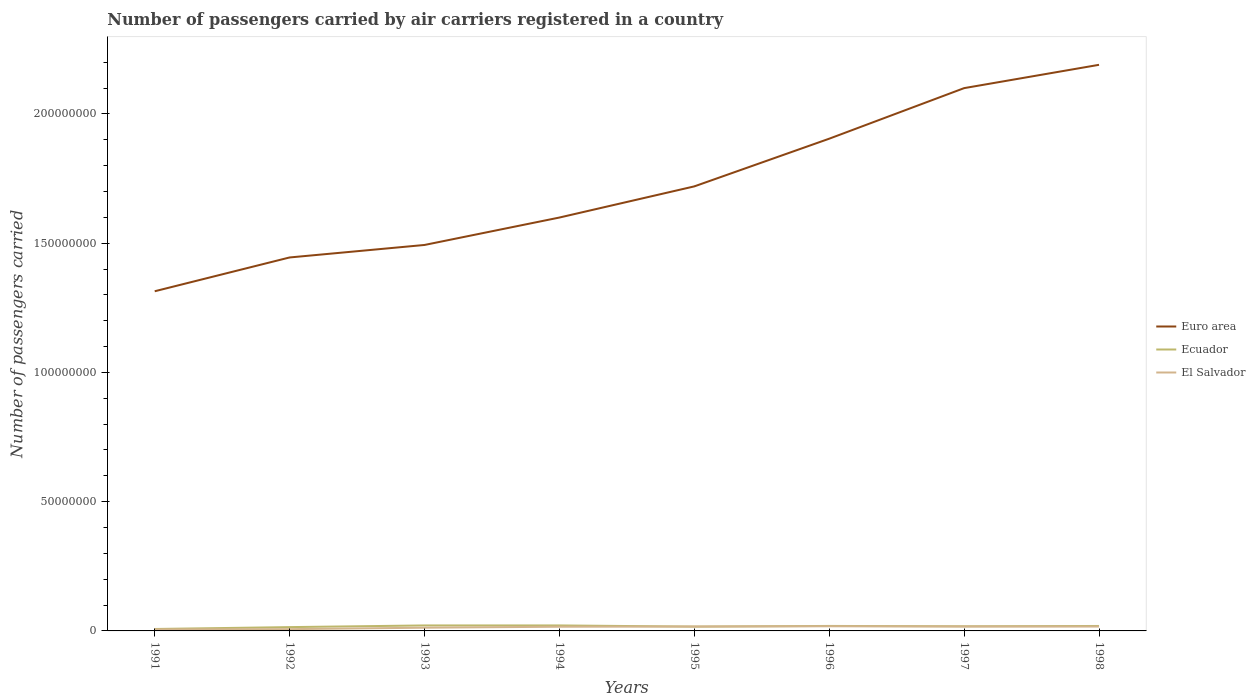Is the number of lines equal to the number of legend labels?
Give a very brief answer. Yes. Across all years, what is the maximum number of passengers carried by air carriers in Ecuador?
Ensure brevity in your answer.  7.52e+05. What is the total number of passengers carried by air carriers in Euro area in the graph?
Provide a short and direct response. -7.45e+07. What is the difference between the highest and the second highest number of passengers carried by air carriers in Ecuador?
Your answer should be very brief. 1.37e+06. How many lines are there?
Offer a terse response. 3. How many years are there in the graph?
Provide a short and direct response. 8. What is the difference between two consecutive major ticks on the Y-axis?
Your answer should be very brief. 5.00e+07. Where does the legend appear in the graph?
Make the answer very short. Center right. What is the title of the graph?
Your response must be concise. Number of passengers carried by air carriers registered in a country. What is the label or title of the Y-axis?
Your answer should be compact. Number of passengers carried. What is the Number of passengers carried of Euro area in 1991?
Provide a succinct answer. 1.31e+08. What is the Number of passengers carried of Ecuador in 1991?
Provide a succinct answer. 7.52e+05. What is the Number of passengers carried of El Salvador in 1991?
Make the answer very short. 5.77e+05. What is the Number of passengers carried of Euro area in 1992?
Your response must be concise. 1.44e+08. What is the Number of passengers carried of Ecuador in 1992?
Keep it short and to the point. 1.47e+06. What is the Number of passengers carried of El Salvador in 1992?
Provide a succinct answer. 6.83e+05. What is the Number of passengers carried of Euro area in 1993?
Keep it short and to the point. 1.49e+08. What is the Number of passengers carried in Ecuador in 1993?
Keep it short and to the point. 2.12e+06. What is the Number of passengers carried in El Salvador in 1993?
Provide a short and direct response. 1.24e+06. What is the Number of passengers carried of Euro area in 1994?
Your response must be concise. 1.60e+08. What is the Number of passengers carried in Ecuador in 1994?
Your answer should be very brief. 2.12e+06. What is the Number of passengers carried in El Salvador in 1994?
Offer a very short reply. 1.62e+06. What is the Number of passengers carried in Euro area in 1995?
Give a very brief answer. 1.72e+08. What is the Number of passengers carried in Ecuador in 1995?
Your answer should be compact. 1.67e+06. What is the Number of passengers carried in El Salvador in 1995?
Offer a terse response. 1.70e+06. What is the Number of passengers carried in Euro area in 1996?
Your answer should be very brief. 1.90e+08. What is the Number of passengers carried of Ecuador in 1996?
Your answer should be compact. 1.93e+06. What is the Number of passengers carried in El Salvador in 1996?
Provide a succinct answer. 1.80e+06. What is the Number of passengers carried in Euro area in 1997?
Make the answer very short. 2.10e+08. What is the Number of passengers carried in Ecuador in 1997?
Offer a terse response. 1.79e+06. What is the Number of passengers carried of El Salvador in 1997?
Your response must be concise. 1.70e+06. What is the Number of passengers carried of Euro area in 1998?
Offer a very short reply. 2.19e+08. What is the Number of passengers carried in Ecuador in 1998?
Offer a very short reply. 1.92e+06. What is the Number of passengers carried in El Salvador in 1998?
Keep it short and to the point. 1.69e+06. Across all years, what is the maximum Number of passengers carried of Euro area?
Give a very brief answer. 2.19e+08. Across all years, what is the maximum Number of passengers carried of Ecuador?
Offer a very short reply. 2.12e+06. Across all years, what is the maximum Number of passengers carried in El Salvador?
Offer a terse response. 1.80e+06. Across all years, what is the minimum Number of passengers carried in Euro area?
Provide a short and direct response. 1.31e+08. Across all years, what is the minimum Number of passengers carried in Ecuador?
Your response must be concise. 7.52e+05. Across all years, what is the minimum Number of passengers carried of El Salvador?
Offer a very short reply. 5.77e+05. What is the total Number of passengers carried in Euro area in the graph?
Offer a terse response. 1.38e+09. What is the total Number of passengers carried in Ecuador in the graph?
Your response must be concise. 1.38e+07. What is the total Number of passengers carried of El Salvador in the graph?
Provide a succinct answer. 1.10e+07. What is the difference between the Number of passengers carried of Euro area in 1991 and that in 1992?
Make the answer very short. -1.31e+07. What is the difference between the Number of passengers carried in Ecuador in 1991 and that in 1992?
Provide a succinct answer. -7.22e+05. What is the difference between the Number of passengers carried of El Salvador in 1991 and that in 1992?
Keep it short and to the point. -1.06e+05. What is the difference between the Number of passengers carried of Euro area in 1991 and that in 1993?
Give a very brief answer. -1.79e+07. What is the difference between the Number of passengers carried in Ecuador in 1991 and that in 1993?
Provide a succinct answer. -1.37e+06. What is the difference between the Number of passengers carried of El Salvador in 1991 and that in 1993?
Your answer should be very brief. -6.65e+05. What is the difference between the Number of passengers carried of Euro area in 1991 and that in 1994?
Ensure brevity in your answer.  -2.85e+07. What is the difference between the Number of passengers carried of Ecuador in 1991 and that in 1994?
Ensure brevity in your answer.  -1.37e+06. What is the difference between the Number of passengers carried of El Salvador in 1991 and that in 1994?
Keep it short and to the point. -1.04e+06. What is the difference between the Number of passengers carried of Euro area in 1991 and that in 1995?
Give a very brief answer. -4.06e+07. What is the difference between the Number of passengers carried in Ecuador in 1991 and that in 1995?
Ensure brevity in your answer.  -9.19e+05. What is the difference between the Number of passengers carried in El Salvador in 1991 and that in 1995?
Give a very brief answer. -1.12e+06. What is the difference between the Number of passengers carried in Euro area in 1991 and that in 1996?
Offer a terse response. -5.90e+07. What is the difference between the Number of passengers carried of Ecuador in 1991 and that in 1996?
Give a very brief answer. -1.17e+06. What is the difference between the Number of passengers carried of El Salvador in 1991 and that in 1996?
Your answer should be very brief. -1.22e+06. What is the difference between the Number of passengers carried in Euro area in 1991 and that in 1997?
Your answer should be very brief. -7.86e+07. What is the difference between the Number of passengers carried of Ecuador in 1991 and that in 1997?
Your answer should be very brief. -1.04e+06. What is the difference between the Number of passengers carried of El Salvador in 1991 and that in 1997?
Give a very brief answer. -1.12e+06. What is the difference between the Number of passengers carried of Euro area in 1991 and that in 1998?
Keep it short and to the point. -8.76e+07. What is the difference between the Number of passengers carried in Ecuador in 1991 and that in 1998?
Provide a short and direct response. -1.17e+06. What is the difference between the Number of passengers carried of El Salvador in 1991 and that in 1998?
Offer a very short reply. -1.12e+06. What is the difference between the Number of passengers carried of Euro area in 1992 and that in 1993?
Make the answer very short. -4.83e+06. What is the difference between the Number of passengers carried of Ecuador in 1992 and that in 1993?
Ensure brevity in your answer.  -6.48e+05. What is the difference between the Number of passengers carried in El Salvador in 1992 and that in 1993?
Offer a very short reply. -5.60e+05. What is the difference between the Number of passengers carried of Euro area in 1992 and that in 1994?
Your answer should be very brief. -1.54e+07. What is the difference between the Number of passengers carried of Ecuador in 1992 and that in 1994?
Offer a terse response. -6.45e+05. What is the difference between the Number of passengers carried in El Salvador in 1992 and that in 1994?
Make the answer very short. -9.34e+05. What is the difference between the Number of passengers carried in Euro area in 1992 and that in 1995?
Offer a very short reply. -2.75e+07. What is the difference between the Number of passengers carried in Ecuador in 1992 and that in 1995?
Ensure brevity in your answer.  -1.97e+05. What is the difference between the Number of passengers carried of El Salvador in 1992 and that in 1995?
Make the answer very short. -1.02e+06. What is the difference between the Number of passengers carried in Euro area in 1992 and that in 1996?
Offer a terse response. -4.59e+07. What is the difference between the Number of passengers carried in Ecuador in 1992 and that in 1996?
Provide a succinct answer. -4.51e+05. What is the difference between the Number of passengers carried of El Salvador in 1992 and that in 1996?
Offer a terse response. -1.12e+06. What is the difference between the Number of passengers carried in Euro area in 1992 and that in 1997?
Provide a short and direct response. -6.55e+07. What is the difference between the Number of passengers carried in Ecuador in 1992 and that in 1997?
Offer a terse response. -3.17e+05. What is the difference between the Number of passengers carried of El Salvador in 1992 and that in 1997?
Ensure brevity in your answer.  -1.02e+06. What is the difference between the Number of passengers carried in Euro area in 1992 and that in 1998?
Give a very brief answer. -7.45e+07. What is the difference between the Number of passengers carried of Ecuador in 1992 and that in 1998?
Provide a short and direct response. -4.45e+05. What is the difference between the Number of passengers carried in El Salvador in 1992 and that in 1998?
Your answer should be very brief. -1.01e+06. What is the difference between the Number of passengers carried of Euro area in 1993 and that in 1994?
Your answer should be very brief. -1.06e+07. What is the difference between the Number of passengers carried in Ecuador in 1993 and that in 1994?
Make the answer very short. 3700. What is the difference between the Number of passengers carried in El Salvador in 1993 and that in 1994?
Ensure brevity in your answer.  -3.75e+05. What is the difference between the Number of passengers carried of Euro area in 1993 and that in 1995?
Provide a short and direct response. -2.27e+07. What is the difference between the Number of passengers carried in Ecuador in 1993 and that in 1995?
Provide a short and direct response. 4.52e+05. What is the difference between the Number of passengers carried of El Salvador in 1993 and that in 1995?
Offer a terse response. -4.56e+05. What is the difference between the Number of passengers carried in Euro area in 1993 and that in 1996?
Keep it short and to the point. -4.11e+07. What is the difference between the Number of passengers carried of Ecuador in 1993 and that in 1996?
Your answer should be compact. 1.97e+05. What is the difference between the Number of passengers carried in El Salvador in 1993 and that in 1996?
Your answer should be compact. -5.58e+05. What is the difference between the Number of passengers carried of Euro area in 1993 and that in 1997?
Offer a terse response. -6.07e+07. What is the difference between the Number of passengers carried of Ecuador in 1993 and that in 1997?
Your answer should be very brief. 3.32e+05. What is the difference between the Number of passengers carried of El Salvador in 1993 and that in 1997?
Offer a very short reply. -4.58e+05. What is the difference between the Number of passengers carried in Euro area in 1993 and that in 1998?
Give a very brief answer. -6.97e+07. What is the difference between the Number of passengers carried of Ecuador in 1993 and that in 1998?
Provide a succinct answer. 2.04e+05. What is the difference between the Number of passengers carried of El Salvador in 1993 and that in 1998?
Provide a succinct answer. -4.52e+05. What is the difference between the Number of passengers carried of Euro area in 1994 and that in 1995?
Your answer should be very brief. -1.21e+07. What is the difference between the Number of passengers carried in Ecuador in 1994 and that in 1995?
Provide a succinct answer. 4.48e+05. What is the difference between the Number of passengers carried in El Salvador in 1994 and that in 1995?
Provide a succinct answer. -8.09e+04. What is the difference between the Number of passengers carried of Euro area in 1994 and that in 1996?
Ensure brevity in your answer.  -3.05e+07. What is the difference between the Number of passengers carried in Ecuador in 1994 and that in 1996?
Provide a succinct answer. 1.94e+05. What is the difference between the Number of passengers carried of El Salvador in 1994 and that in 1996?
Your response must be concise. -1.83e+05. What is the difference between the Number of passengers carried of Euro area in 1994 and that in 1997?
Your answer should be very brief. -5.01e+07. What is the difference between the Number of passengers carried in Ecuador in 1994 and that in 1997?
Keep it short and to the point. 3.28e+05. What is the difference between the Number of passengers carried of El Salvador in 1994 and that in 1997?
Offer a very short reply. -8.35e+04. What is the difference between the Number of passengers carried in Euro area in 1994 and that in 1998?
Your answer should be compact. -5.91e+07. What is the difference between the Number of passengers carried of Ecuador in 1994 and that in 1998?
Provide a short and direct response. 2.00e+05. What is the difference between the Number of passengers carried in El Salvador in 1994 and that in 1998?
Your response must be concise. -7.69e+04. What is the difference between the Number of passengers carried in Euro area in 1995 and that in 1996?
Offer a very short reply. -1.84e+07. What is the difference between the Number of passengers carried in Ecuador in 1995 and that in 1996?
Keep it short and to the point. -2.54e+05. What is the difference between the Number of passengers carried of El Salvador in 1995 and that in 1996?
Make the answer very short. -1.02e+05. What is the difference between the Number of passengers carried in Euro area in 1995 and that in 1997?
Offer a terse response. -3.80e+07. What is the difference between the Number of passengers carried of Ecuador in 1995 and that in 1997?
Make the answer very short. -1.20e+05. What is the difference between the Number of passengers carried in El Salvador in 1995 and that in 1997?
Make the answer very short. -2600. What is the difference between the Number of passengers carried in Euro area in 1995 and that in 1998?
Offer a terse response. -4.70e+07. What is the difference between the Number of passengers carried of Ecuador in 1995 and that in 1998?
Your response must be concise. -2.48e+05. What is the difference between the Number of passengers carried in El Salvador in 1995 and that in 1998?
Your response must be concise. 4000. What is the difference between the Number of passengers carried of Euro area in 1996 and that in 1997?
Provide a succinct answer. -1.96e+07. What is the difference between the Number of passengers carried in Ecuador in 1996 and that in 1997?
Your answer should be compact. 1.35e+05. What is the difference between the Number of passengers carried in El Salvador in 1996 and that in 1997?
Make the answer very short. 9.94e+04. What is the difference between the Number of passengers carried in Euro area in 1996 and that in 1998?
Your answer should be very brief. -2.86e+07. What is the difference between the Number of passengers carried of Ecuador in 1996 and that in 1998?
Provide a succinct answer. 6400. What is the difference between the Number of passengers carried of El Salvador in 1996 and that in 1998?
Give a very brief answer. 1.06e+05. What is the difference between the Number of passengers carried of Euro area in 1997 and that in 1998?
Your answer should be compact. -9.02e+06. What is the difference between the Number of passengers carried in Ecuador in 1997 and that in 1998?
Your response must be concise. -1.28e+05. What is the difference between the Number of passengers carried of El Salvador in 1997 and that in 1998?
Provide a short and direct response. 6600. What is the difference between the Number of passengers carried in Euro area in 1991 and the Number of passengers carried in Ecuador in 1992?
Your answer should be compact. 1.30e+08. What is the difference between the Number of passengers carried of Euro area in 1991 and the Number of passengers carried of El Salvador in 1992?
Offer a very short reply. 1.31e+08. What is the difference between the Number of passengers carried of Ecuador in 1991 and the Number of passengers carried of El Salvador in 1992?
Your response must be concise. 6.94e+04. What is the difference between the Number of passengers carried of Euro area in 1991 and the Number of passengers carried of Ecuador in 1993?
Provide a short and direct response. 1.29e+08. What is the difference between the Number of passengers carried in Euro area in 1991 and the Number of passengers carried in El Salvador in 1993?
Make the answer very short. 1.30e+08. What is the difference between the Number of passengers carried of Ecuador in 1991 and the Number of passengers carried of El Salvador in 1993?
Offer a terse response. -4.90e+05. What is the difference between the Number of passengers carried of Euro area in 1991 and the Number of passengers carried of Ecuador in 1994?
Offer a terse response. 1.29e+08. What is the difference between the Number of passengers carried in Euro area in 1991 and the Number of passengers carried in El Salvador in 1994?
Make the answer very short. 1.30e+08. What is the difference between the Number of passengers carried in Ecuador in 1991 and the Number of passengers carried in El Salvador in 1994?
Your answer should be compact. -8.65e+05. What is the difference between the Number of passengers carried of Euro area in 1991 and the Number of passengers carried of Ecuador in 1995?
Offer a very short reply. 1.30e+08. What is the difference between the Number of passengers carried in Euro area in 1991 and the Number of passengers carried in El Salvador in 1995?
Offer a very short reply. 1.30e+08. What is the difference between the Number of passengers carried of Ecuador in 1991 and the Number of passengers carried of El Salvador in 1995?
Offer a terse response. -9.46e+05. What is the difference between the Number of passengers carried in Euro area in 1991 and the Number of passengers carried in Ecuador in 1996?
Your answer should be compact. 1.29e+08. What is the difference between the Number of passengers carried of Euro area in 1991 and the Number of passengers carried of El Salvador in 1996?
Give a very brief answer. 1.30e+08. What is the difference between the Number of passengers carried of Ecuador in 1991 and the Number of passengers carried of El Salvador in 1996?
Offer a very short reply. -1.05e+06. What is the difference between the Number of passengers carried in Euro area in 1991 and the Number of passengers carried in Ecuador in 1997?
Ensure brevity in your answer.  1.30e+08. What is the difference between the Number of passengers carried in Euro area in 1991 and the Number of passengers carried in El Salvador in 1997?
Keep it short and to the point. 1.30e+08. What is the difference between the Number of passengers carried in Ecuador in 1991 and the Number of passengers carried in El Salvador in 1997?
Provide a succinct answer. -9.48e+05. What is the difference between the Number of passengers carried of Euro area in 1991 and the Number of passengers carried of Ecuador in 1998?
Your answer should be very brief. 1.29e+08. What is the difference between the Number of passengers carried in Euro area in 1991 and the Number of passengers carried in El Salvador in 1998?
Make the answer very short. 1.30e+08. What is the difference between the Number of passengers carried in Ecuador in 1991 and the Number of passengers carried in El Salvador in 1998?
Provide a short and direct response. -9.42e+05. What is the difference between the Number of passengers carried in Euro area in 1992 and the Number of passengers carried in Ecuador in 1993?
Keep it short and to the point. 1.42e+08. What is the difference between the Number of passengers carried in Euro area in 1992 and the Number of passengers carried in El Salvador in 1993?
Offer a very short reply. 1.43e+08. What is the difference between the Number of passengers carried in Ecuador in 1992 and the Number of passengers carried in El Salvador in 1993?
Give a very brief answer. 2.31e+05. What is the difference between the Number of passengers carried of Euro area in 1992 and the Number of passengers carried of Ecuador in 1994?
Ensure brevity in your answer.  1.42e+08. What is the difference between the Number of passengers carried of Euro area in 1992 and the Number of passengers carried of El Salvador in 1994?
Give a very brief answer. 1.43e+08. What is the difference between the Number of passengers carried of Ecuador in 1992 and the Number of passengers carried of El Salvador in 1994?
Your response must be concise. -1.43e+05. What is the difference between the Number of passengers carried of Euro area in 1992 and the Number of passengers carried of Ecuador in 1995?
Keep it short and to the point. 1.43e+08. What is the difference between the Number of passengers carried in Euro area in 1992 and the Number of passengers carried in El Salvador in 1995?
Your answer should be very brief. 1.43e+08. What is the difference between the Number of passengers carried of Ecuador in 1992 and the Number of passengers carried of El Salvador in 1995?
Give a very brief answer. -2.24e+05. What is the difference between the Number of passengers carried in Euro area in 1992 and the Number of passengers carried in Ecuador in 1996?
Offer a very short reply. 1.43e+08. What is the difference between the Number of passengers carried in Euro area in 1992 and the Number of passengers carried in El Salvador in 1996?
Make the answer very short. 1.43e+08. What is the difference between the Number of passengers carried in Ecuador in 1992 and the Number of passengers carried in El Salvador in 1996?
Provide a short and direct response. -3.26e+05. What is the difference between the Number of passengers carried of Euro area in 1992 and the Number of passengers carried of Ecuador in 1997?
Your answer should be compact. 1.43e+08. What is the difference between the Number of passengers carried in Euro area in 1992 and the Number of passengers carried in El Salvador in 1997?
Offer a very short reply. 1.43e+08. What is the difference between the Number of passengers carried of Ecuador in 1992 and the Number of passengers carried of El Salvador in 1997?
Make the answer very short. -2.27e+05. What is the difference between the Number of passengers carried in Euro area in 1992 and the Number of passengers carried in Ecuador in 1998?
Provide a short and direct response. 1.43e+08. What is the difference between the Number of passengers carried of Euro area in 1992 and the Number of passengers carried of El Salvador in 1998?
Provide a succinct answer. 1.43e+08. What is the difference between the Number of passengers carried of Ecuador in 1992 and the Number of passengers carried of El Salvador in 1998?
Offer a terse response. -2.20e+05. What is the difference between the Number of passengers carried in Euro area in 1993 and the Number of passengers carried in Ecuador in 1994?
Ensure brevity in your answer.  1.47e+08. What is the difference between the Number of passengers carried of Euro area in 1993 and the Number of passengers carried of El Salvador in 1994?
Your response must be concise. 1.48e+08. What is the difference between the Number of passengers carried in Ecuador in 1993 and the Number of passengers carried in El Salvador in 1994?
Make the answer very short. 5.05e+05. What is the difference between the Number of passengers carried in Euro area in 1993 and the Number of passengers carried in Ecuador in 1995?
Keep it short and to the point. 1.48e+08. What is the difference between the Number of passengers carried of Euro area in 1993 and the Number of passengers carried of El Salvador in 1995?
Provide a short and direct response. 1.48e+08. What is the difference between the Number of passengers carried in Ecuador in 1993 and the Number of passengers carried in El Salvador in 1995?
Provide a succinct answer. 4.24e+05. What is the difference between the Number of passengers carried in Euro area in 1993 and the Number of passengers carried in Ecuador in 1996?
Ensure brevity in your answer.  1.47e+08. What is the difference between the Number of passengers carried of Euro area in 1993 and the Number of passengers carried of El Salvador in 1996?
Provide a succinct answer. 1.48e+08. What is the difference between the Number of passengers carried of Ecuador in 1993 and the Number of passengers carried of El Salvador in 1996?
Give a very brief answer. 3.22e+05. What is the difference between the Number of passengers carried in Euro area in 1993 and the Number of passengers carried in Ecuador in 1997?
Provide a succinct answer. 1.48e+08. What is the difference between the Number of passengers carried of Euro area in 1993 and the Number of passengers carried of El Salvador in 1997?
Ensure brevity in your answer.  1.48e+08. What is the difference between the Number of passengers carried in Ecuador in 1993 and the Number of passengers carried in El Salvador in 1997?
Make the answer very short. 4.22e+05. What is the difference between the Number of passengers carried in Euro area in 1993 and the Number of passengers carried in Ecuador in 1998?
Ensure brevity in your answer.  1.47e+08. What is the difference between the Number of passengers carried in Euro area in 1993 and the Number of passengers carried in El Salvador in 1998?
Offer a very short reply. 1.48e+08. What is the difference between the Number of passengers carried of Ecuador in 1993 and the Number of passengers carried of El Salvador in 1998?
Make the answer very short. 4.28e+05. What is the difference between the Number of passengers carried of Euro area in 1994 and the Number of passengers carried of Ecuador in 1995?
Ensure brevity in your answer.  1.58e+08. What is the difference between the Number of passengers carried of Euro area in 1994 and the Number of passengers carried of El Salvador in 1995?
Ensure brevity in your answer.  1.58e+08. What is the difference between the Number of passengers carried in Ecuador in 1994 and the Number of passengers carried in El Salvador in 1995?
Offer a very short reply. 4.21e+05. What is the difference between the Number of passengers carried in Euro area in 1994 and the Number of passengers carried in Ecuador in 1996?
Ensure brevity in your answer.  1.58e+08. What is the difference between the Number of passengers carried in Euro area in 1994 and the Number of passengers carried in El Salvador in 1996?
Your answer should be compact. 1.58e+08. What is the difference between the Number of passengers carried of Ecuador in 1994 and the Number of passengers carried of El Salvador in 1996?
Provide a short and direct response. 3.19e+05. What is the difference between the Number of passengers carried of Euro area in 1994 and the Number of passengers carried of Ecuador in 1997?
Your answer should be compact. 1.58e+08. What is the difference between the Number of passengers carried of Euro area in 1994 and the Number of passengers carried of El Salvador in 1997?
Keep it short and to the point. 1.58e+08. What is the difference between the Number of passengers carried in Ecuador in 1994 and the Number of passengers carried in El Salvador in 1997?
Your answer should be very brief. 4.18e+05. What is the difference between the Number of passengers carried of Euro area in 1994 and the Number of passengers carried of Ecuador in 1998?
Your answer should be very brief. 1.58e+08. What is the difference between the Number of passengers carried in Euro area in 1994 and the Number of passengers carried in El Salvador in 1998?
Provide a succinct answer. 1.58e+08. What is the difference between the Number of passengers carried of Ecuador in 1994 and the Number of passengers carried of El Salvador in 1998?
Provide a short and direct response. 4.25e+05. What is the difference between the Number of passengers carried of Euro area in 1995 and the Number of passengers carried of Ecuador in 1996?
Keep it short and to the point. 1.70e+08. What is the difference between the Number of passengers carried in Euro area in 1995 and the Number of passengers carried in El Salvador in 1996?
Offer a very short reply. 1.70e+08. What is the difference between the Number of passengers carried in Ecuador in 1995 and the Number of passengers carried in El Salvador in 1996?
Keep it short and to the point. -1.29e+05. What is the difference between the Number of passengers carried of Euro area in 1995 and the Number of passengers carried of Ecuador in 1997?
Offer a very short reply. 1.70e+08. What is the difference between the Number of passengers carried in Euro area in 1995 and the Number of passengers carried in El Salvador in 1997?
Offer a terse response. 1.70e+08. What is the difference between the Number of passengers carried of Ecuador in 1995 and the Number of passengers carried of El Salvador in 1997?
Offer a terse response. -2.97e+04. What is the difference between the Number of passengers carried of Euro area in 1995 and the Number of passengers carried of Ecuador in 1998?
Keep it short and to the point. 1.70e+08. What is the difference between the Number of passengers carried of Euro area in 1995 and the Number of passengers carried of El Salvador in 1998?
Provide a succinct answer. 1.70e+08. What is the difference between the Number of passengers carried of Ecuador in 1995 and the Number of passengers carried of El Salvador in 1998?
Keep it short and to the point. -2.31e+04. What is the difference between the Number of passengers carried in Euro area in 1996 and the Number of passengers carried in Ecuador in 1997?
Your answer should be compact. 1.89e+08. What is the difference between the Number of passengers carried in Euro area in 1996 and the Number of passengers carried in El Salvador in 1997?
Provide a succinct answer. 1.89e+08. What is the difference between the Number of passengers carried in Ecuador in 1996 and the Number of passengers carried in El Salvador in 1997?
Provide a short and direct response. 2.25e+05. What is the difference between the Number of passengers carried in Euro area in 1996 and the Number of passengers carried in Ecuador in 1998?
Make the answer very short. 1.89e+08. What is the difference between the Number of passengers carried of Euro area in 1996 and the Number of passengers carried of El Salvador in 1998?
Offer a very short reply. 1.89e+08. What is the difference between the Number of passengers carried in Ecuador in 1996 and the Number of passengers carried in El Salvador in 1998?
Provide a short and direct response. 2.31e+05. What is the difference between the Number of passengers carried of Euro area in 1997 and the Number of passengers carried of Ecuador in 1998?
Keep it short and to the point. 2.08e+08. What is the difference between the Number of passengers carried of Euro area in 1997 and the Number of passengers carried of El Salvador in 1998?
Offer a terse response. 2.08e+08. What is the difference between the Number of passengers carried of Ecuador in 1997 and the Number of passengers carried of El Salvador in 1998?
Keep it short and to the point. 9.66e+04. What is the average Number of passengers carried in Euro area per year?
Your response must be concise. 1.72e+08. What is the average Number of passengers carried in Ecuador per year?
Offer a terse response. 1.72e+06. What is the average Number of passengers carried in El Salvador per year?
Your response must be concise. 1.38e+06. In the year 1991, what is the difference between the Number of passengers carried of Euro area and Number of passengers carried of Ecuador?
Your answer should be very brief. 1.31e+08. In the year 1991, what is the difference between the Number of passengers carried of Euro area and Number of passengers carried of El Salvador?
Offer a terse response. 1.31e+08. In the year 1991, what is the difference between the Number of passengers carried in Ecuador and Number of passengers carried in El Salvador?
Offer a very short reply. 1.75e+05. In the year 1992, what is the difference between the Number of passengers carried of Euro area and Number of passengers carried of Ecuador?
Give a very brief answer. 1.43e+08. In the year 1992, what is the difference between the Number of passengers carried in Euro area and Number of passengers carried in El Salvador?
Provide a succinct answer. 1.44e+08. In the year 1992, what is the difference between the Number of passengers carried in Ecuador and Number of passengers carried in El Salvador?
Keep it short and to the point. 7.91e+05. In the year 1993, what is the difference between the Number of passengers carried in Euro area and Number of passengers carried in Ecuador?
Offer a terse response. 1.47e+08. In the year 1993, what is the difference between the Number of passengers carried of Euro area and Number of passengers carried of El Salvador?
Make the answer very short. 1.48e+08. In the year 1993, what is the difference between the Number of passengers carried in Ecuador and Number of passengers carried in El Salvador?
Give a very brief answer. 8.80e+05. In the year 1994, what is the difference between the Number of passengers carried in Euro area and Number of passengers carried in Ecuador?
Offer a terse response. 1.58e+08. In the year 1994, what is the difference between the Number of passengers carried in Euro area and Number of passengers carried in El Salvador?
Your answer should be compact. 1.58e+08. In the year 1994, what is the difference between the Number of passengers carried of Ecuador and Number of passengers carried of El Salvador?
Provide a succinct answer. 5.02e+05. In the year 1995, what is the difference between the Number of passengers carried of Euro area and Number of passengers carried of Ecuador?
Make the answer very short. 1.70e+08. In the year 1995, what is the difference between the Number of passengers carried of Euro area and Number of passengers carried of El Salvador?
Your answer should be very brief. 1.70e+08. In the year 1995, what is the difference between the Number of passengers carried of Ecuador and Number of passengers carried of El Salvador?
Your answer should be compact. -2.71e+04. In the year 1996, what is the difference between the Number of passengers carried in Euro area and Number of passengers carried in Ecuador?
Your answer should be compact. 1.89e+08. In the year 1996, what is the difference between the Number of passengers carried of Euro area and Number of passengers carried of El Salvador?
Keep it short and to the point. 1.89e+08. In the year 1996, what is the difference between the Number of passengers carried in Ecuador and Number of passengers carried in El Salvador?
Offer a very short reply. 1.25e+05. In the year 1997, what is the difference between the Number of passengers carried of Euro area and Number of passengers carried of Ecuador?
Make the answer very short. 2.08e+08. In the year 1997, what is the difference between the Number of passengers carried of Euro area and Number of passengers carried of El Salvador?
Keep it short and to the point. 2.08e+08. In the year 1998, what is the difference between the Number of passengers carried in Euro area and Number of passengers carried in Ecuador?
Keep it short and to the point. 2.17e+08. In the year 1998, what is the difference between the Number of passengers carried in Euro area and Number of passengers carried in El Salvador?
Keep it short and to the point. 2.17e+08. In the year 1998, what is the difference between the Number of passengers carried in Ecuador and Number of passengers carried in El Salvador?
Your answer should be very brief. 2.25e+05. What is the ratio of the Number of passengers carried of Euro area in 1991 to that in 1992?
Keep it short and to the point. 0.91. What is the ratio of the Number of passengers carried in Ecuador in 1991 to that in 1992?
Offer a terse response. 0.51. What is the ratio of the Number of passengers carried of El Salvador in 1991 to that in 1992?
Offer a terse response. 0.85. What is the ratio of the Number of passengers carried in Euro area in 1991 to that in 1993?
Provide a succinct answer. 0.88. What is the ratio of the Number of passengers carried of Ecuador in 1991 to that in 1993?
Make the answer very short. 0.35. What is the ratio of the Number of passengers carried of El Salvador in 1991 to that in 1993?
Make the answer very short. 0.46. What is the ratio of the Number of passengers carried of Euro area in 1991 to that in 1994?
Make the answer very short. 0.82. What is the ratio of the Number of passengers carried of Ecuador in 1991 to that in 1994?
Offer a terse response. 0.36. What is the ratio of the Number of passengers carried of El Salvador in 1991 to that in 1994?
Your response must be concise. 0.36. What is the ratio of the Number of passengers carried of Euro area in 1991 to that in 1995?
Offer a very short reply. 0.76. What is the ratio of the Number of passengers carried of Ecuador in 1991 to that in 1995?
Make the answer very short. 0.45. What is the ratio of the Number of passengers carried in El Salvador in 1991 to that in 1995?
Offer a very short reply. 0.34. What is the ratio of the Number of passengers carried of Euro area in 1991 to that in 1996?
Give a very brief answer. 0.69. What is the ratio of the Number of passengers carried of Ecuador in 1991 to that in 1996?
Keep it short and to the point. 0.39. What is the ratio of the Number of passengers carried of El Salvador in 1991 to that in 1996?
Make the answer very short. 0.32. What is the ratio of the Number of passengers carried in Euro area in 1991 to that in 1997?
Offer a terse response. 0.63. What is the ratio of the Number of passengers carried in Ecuador in 1991 to that in 1997?
Provide a short and direct response. 0.42. What is the ratio of the Number of passengers carried in El Salvador in 1991 to that in 1997?
Ensure brevity in your answer.  0.34. What is the ratio of the Number of passengers carried in Ecuador in 1991 to that in 1998?
Make the answer very short. 0.39. What is the ratio of the Number of passengers carried in El Salvador in 1991 to that in 1998?
Your answer should be very brief. 0.34. What is the ratio of the Number of passengers carried in Euro area in 1992 to that in 1993?
Offer a terse response. 0.97. What is the ratio of the Number of passengers carried of Ecuador in 1992 to that in 1993?
Offer a very short reply. 0.69. What is the ratio of the Number of passengers carried of El Salvador in 1992 to that in 1993?
Your answer should be compact. 0.55. What is the ratio of the Number of passengers carried in Euro area in 1992 to that in 1994?
Your response must be concise. 0.9. What is the ratio of the Number of passengers carried of Ecuador in 1992 to that in 1994?
Keep it short and to the point. 0.7. What is the ratio of the Number of passengers carried of El Salvador in 1992 to that in 1994?
Make the answer very short. 0.42. What is the ratio of the Number of passengers carried in Euro area in 1992 to that in 1995?
Offer a very short reply. 0.84. What is the ratio of the Number of passengers carried in Ecuador in 1992 to that in 1995?
Offer a very short reply. 0.88. What is the ratio of the Number of passengers carried of El Salvador in 1992 to that in 1995?
Give a very brief answer. 0.4. What is the ratio of the Number of passengers carried of Euro area in 1992 to that in 1996?
Ensure brevity in your answer.  0.76. What is the ratio of the Number of passengers carried in Ecuador in 1992 to that in 1996?
Provide a succinct answer. 0.77. What is the ratio of the Number of passengers carried in El Salvador in 1992 to that in 1996?
Offer a terse response. 0.38. What is the ratio of the Number of passengers carried in Euro area in 1992 to that in 1997?
Make the answer very short. 0.69. What is the ratio of the Number of passengers carried of Ecuador in 1992 to that in 1997?
Keep it short and to the point. 0.82. What is the ratio of the Number of passengers carried of El Salvador in 1992 to that in 1997?
Your response must be concise. 0.4. What is the ratio of the Number of passengers carried in Euro area in 1992 to that in 1998?
Provide a short and direct response. 0.66. What is the ratio of the Number of passengers carried of Ecuador in 1992 to that in 1998?
Provide a short and direct response. 0.77. What is the ratio of the Number of passengers carried of El Salvador in 1992 to that in 1998?
Give a very brief answer. 0.4. What is the ratio of the Number of passengers carried in Euro area in 1993 to that in 1994?
Give a very brief answer. 0.93. What is the ratio of the Number of passengers carried in El Salvador in 1993 to that in 1994?
Keep it short and to the point. 0.77. What is the ratio of the Number of passengers carried of Euro area in 1993 to that in 1995?
Ensure brevity in your answer.  0.87. What is the ratio of the Number of passengers carried in Ecuador in 1993 to that in 1995?
Keep it short and to the point. 1.27. What is the ratio of the Number of passengers carried of El Salvador in 1993 to that in 1995?
Offer a terse response. 0.73. What is the ratio of the Number of passengers carried in Euro area in 1993 to that in 1996?
Your answer should be compact. 0.78. What is the ratio of the Number of passengers carried of Ecuador in 1993 to that in 1996?
Ensure brevity in your answer.  1.1. What is the ratio of the Number of passengers carried in El Salvador in 1993 to that in 1996?
Your answer should be very brief. 0.69. What is the ratio of the Number of passengers carried of Euro area in 1993 to that in 1997?
Your answer should be very brief. 0.71. What is the ratio of the Number of passengers carried of Ecuador in 1993 to that in 1997?
Provide a succinct answer. 1.19. What is the ratio of the Number of passengers carried in El Salvador in 1993 to that in 1997?
Make the answer very short. 0.73. What is the ratio of the Number of passengers carried of Euro area in 1993 to that in 1998?
Give a very brief answer. 0.68. What is the ratio of the Number of passengers carried in Ecuador in 1993 to that in 1998?
Your answer should be very brief. 1.11. What is the ratio of the Number of passengers carried in El Salvador in 1993 to that in 1998?
Offer a very short reply. 0.73. What is the ratio of the Number of passengers carried of Euro area in 1994 to that in 1995?
Ensure brevity in your answer.  0.93. What is the ratio of the Number of passengers carried of Ecuador in 1994 to that in 1995?
Your answer should be very brief. 1.27. What is the ratio of the Number of passengers carried in Euro area in 1994 to that in 1996?
Ensure brevity in your answer.  0.84. What is the ratio of the Number of passengers carried in Ecuador in 1994 to that in 1996?
Offer a very short reply. 1.1. What is the ratio of the Number of passengers carried of El Salvador in 1994 to that in 1996?
Ensure brevity in your answer.  0.9. What is the ratio of the Number of passengers carried of Euro area in 1994 to that in 1997?
Offer a terse response. 0.76. What is the ratio of the Number of passengers carried in Ecuador in 1994 to that in 1997?
Ensure brevity in your answer.  1.18. What is the ratio of the Number of passengers carried of El Salvador in 1994 to that in 1997?
Provide a succinct answer. 0.95. What is the ratio of the Number of passengers carried in Euro area in 1994 to that in 1998?
Make the answer very short. 0.73. What is the ratio of the Number of passengers carried in Ecuador in 1994 to that in 1998?
Provide a short and direct response. 1.1. What is the ratio of the Number of passengers carried in El Salvador in 1994 to that in 1998?
Your answer should be compact. 0.95. What is the ratio of the Number of passengers carried in Euro area in 1995 to that in 1996?
Provide a succinct answer. 0.9. What is the ratio of the Number of passengers carried in Ecuador in 1995 to that in 1996?
Provide a short and direct response. 0.87. What is the ratio of the Number of passengers carried of El Salvador in 1995 to that in 1996?
Give a very brief answer. 0.94. What is the ratio of the Number of passengers carried in Euro area in 1995 to that in 1997?
Your response must be concise. 0.82. What is the ratio of the Number of passengers carried in Ecuador in 1995 to that in 1997?
Offer a very short reply. 0.93. What is the ratio of the Number of passengers carried of El Salvador in 1995 to that in 1997?
Your response must be concise. 1. What is the ratio of the Number of passengers carried in Euro area in 1995 to that in 1998?
Give a very brief answer. 0.79. What is the ratio of the Number of passengers carried in Ecuador in 1995 to that in 1998?
Make the answer very short. 0.87. What is the ratio of the Number of passengers carried in El Salvador in 1995 to that in 1998?
Provide a short and direct response. 1. What is the ratio of the Number of passengers carried of Euro area in 1996 to that in 1997?
Offer a terse response. 0.91. What is the ratio of the Number of passengers carried in Ecuador in 1996 to that in 1997?
Offer a very short reply. 1.08. What is the ratio of the Number of passengers carried of El Salvador in 1996 to that in 1997?
Provide a succinct answer. 1.06. What is the ratio of the Number of passengers carried of Euro area in 1996 to that in 1998?
Make the answer very short. 0.87. What is the ratio of the Number of passengers carried in El Salvador in 1996 to that in 1998?
Give a very brief answer. 1.06. What is the ratio of the Number of passengers carried in Euro area in 1997 to that in 1998?
Give a very brief answer. 0.96. What is the ratio of the Number of passengers carried in Ecuador in 1997 to that in 1998?
Offer a very short reply. 0.93. What is the ratio of the Number of passengers carried of El Salvador in 1997 to that in 1998?
Provide a short and direct response. 1. What is the difference between the highest and the second highest Number of passengers carried in Euro area?
Keep it short and to the point. 9.02e+06. What is the difference between the highest and the second highest Number of passengers carried in Ecuador?
Your response must be concise. 3700. What is the difference between the highest and the second highest Number of passengers carried in El Salvador?
Give a very brief answer. 9.94e+04. What is the difference between the highest and the lowest Number of passengers carried in Euro area?
Provide a short and direct response. 8.76e+07. What is the difference between the highest and the lowest Number of passengers carried of Ecuador?
Provide a short and direct response. 1.37e+06. What is the difference between the highest and the lowest Number of passengers carried of El Salvador?
Your response must be concise. 1.22e+06. 